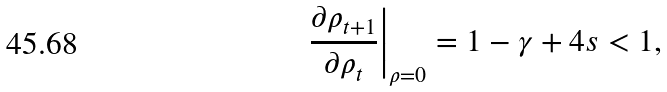<formula> <loc_0><loc_0><loc_500><loc_500>\left . \frac { \partial { \rho _ { t + 1 } } } { \partial { \rho _ { t } } } \right | _ { \rho = 0 } = 1 - \gamma + 4 s < 1 ,</formula> 